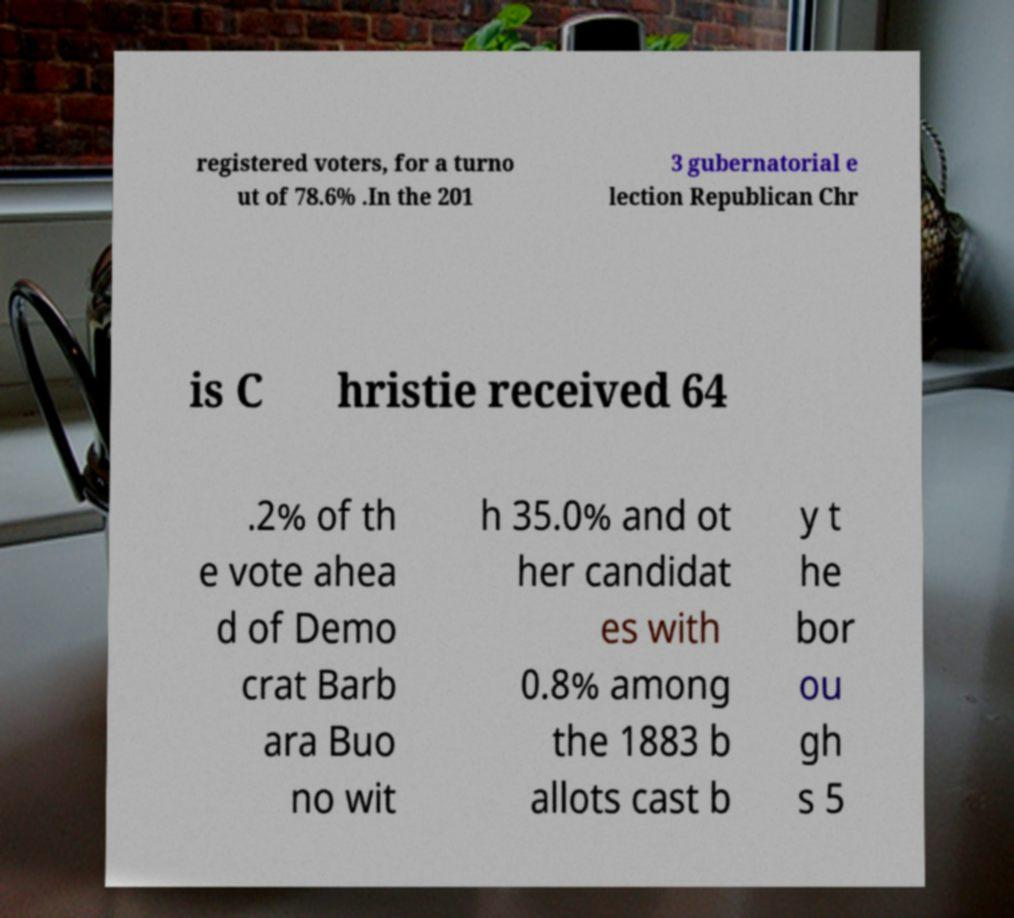Can you read and provide the text displayed in the image?This photo seems to have some interesting text. Can you extract and type it out for me? registered voters, for a turno ut of 78.6% .In the 201 3 gubernatorial e lection Republican Chr is C hristie received 64 .2% of th e vote ahea d of Demo crat Barb ara Buo no wit h 35.0% and ot her candidat es with 0.8% among the 1883 b allots cast b y t he bor ou gh s 5 